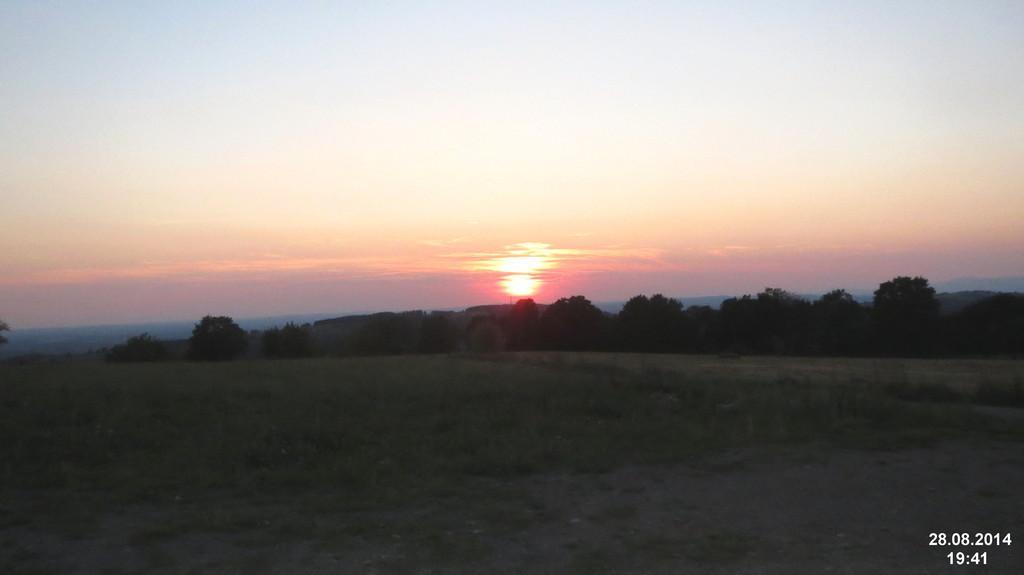Can you describe this image briefly? In this picture I can see trees. I can see green grass. I can see clouds in the sky. 